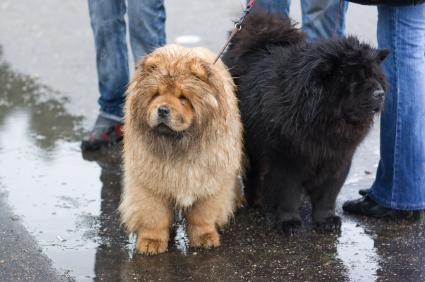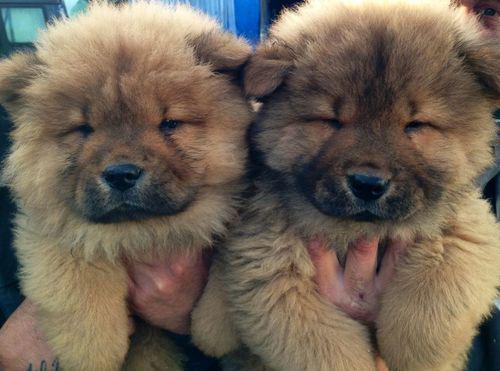The first image is the image on the left, the second image is the image on the right. For the images displayed, is the sentence "Exactly four dogs are shown in groups of two." factually correct? Answer yes or no. Yes. 